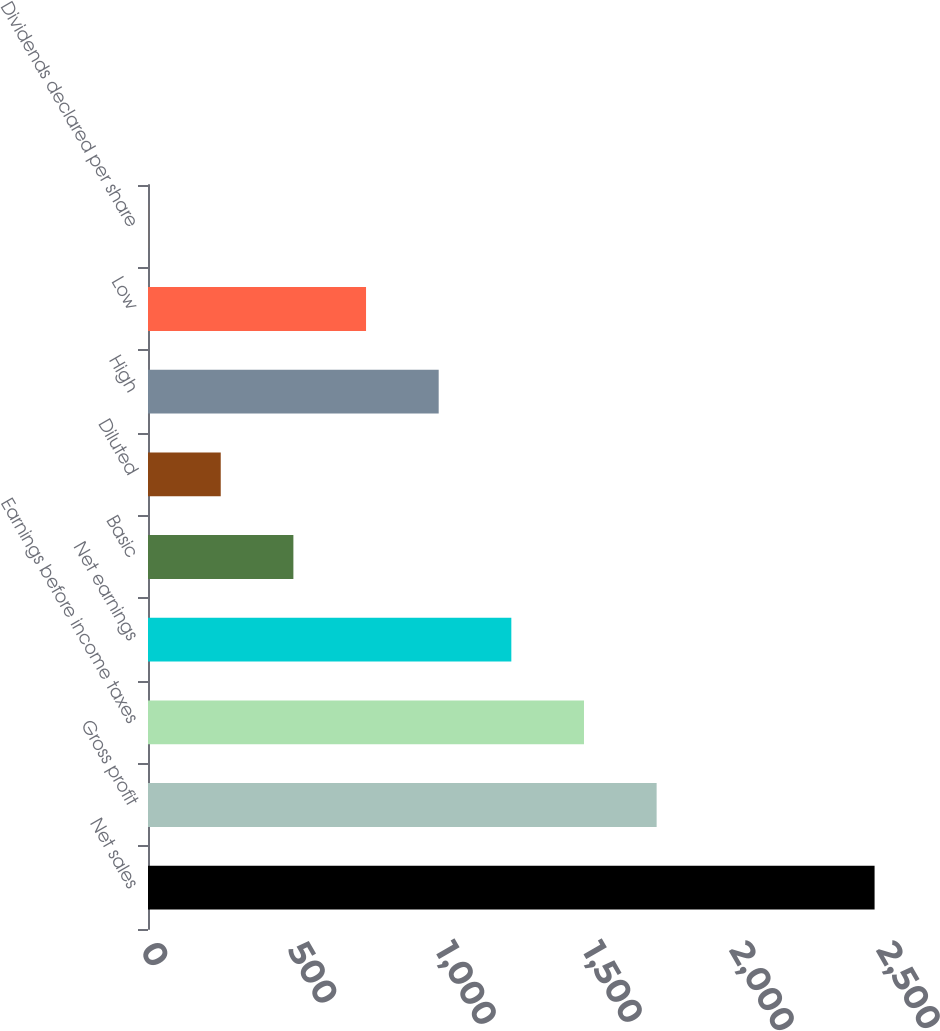Convert chart to OTSL. <chart><loc_0><loc_0><loc_500><loc_500><bar_chart><fcel>Net sales<fcel>Gross profit<fcel>Earnings before income taxes<fcel>Net earnings<fcel>Basic<fcel>Diluted<fcel>High<fcel>Low<fcel>Dividends declared per share<nl><fcel>2468<fcel>1727.69<fcel>1480.92<fcel>1234.15<fcel>493.84<fcel>247.07<fcel>987.38<fcel>740.61<fcel>0.3<nl></chart> 